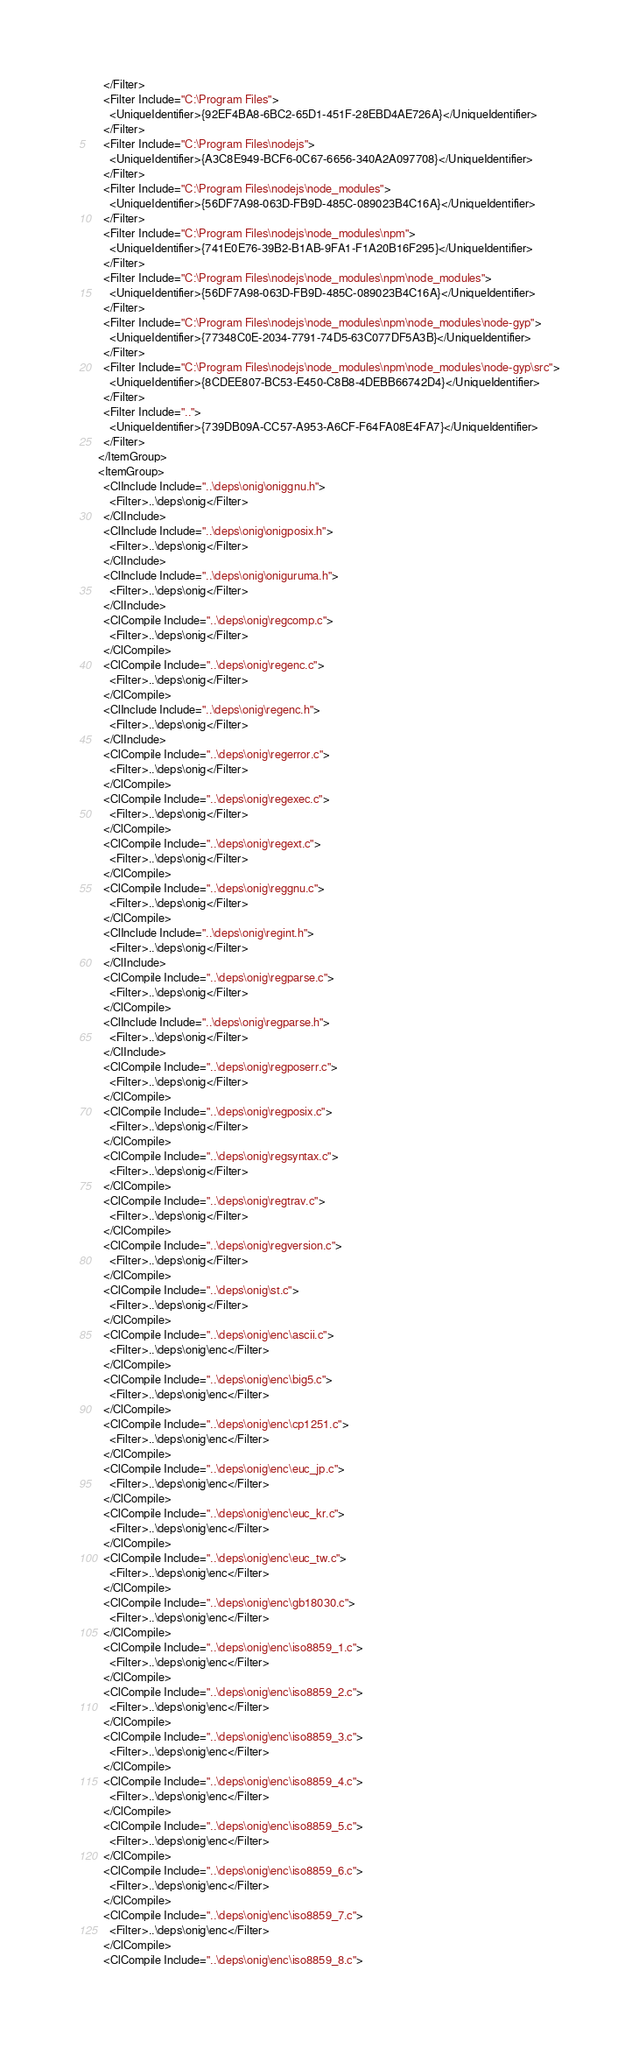<code> <loc_0><loc_0><loc_500><loc_500><_XML_>    </Filter>
    <Filter Include="C:\Program Files">
      <UniqueIdentifier>{92EF4BA8-6BC2-65D1-451F-28EBD4AE726A}</UniqueIdentifier>
    </Filter>
    <Filter Include="C:\Program Files\nodejs">
      <UniqueIdentifier>{A3C8E949-BCF6-0C67-6656-340A2A097708}</UniqueIdentifier>
    </Filter>
    <Filter Include="C:\Program Files\nodejs\node_modules">
      <UniqueIdentifier>{56DF7A98-063D-FB9D-485C-089023B4C16A}</UniqueIdentifier>
    </Filter>
    <Filter Include="C:\Program Files\nodejs\node_modules\npm">
      <UniqueIdentifier>{741E0E76-39B2-B1AB-9FA1-F1A20B16F295}</UniqueIdentifier>
    </Filter>
    <Filter Include="C:\Program Files\nodejs\node_modules\npm\node_modules">
      <UniqueIdentifier>{56DF7A98-063D-FB9D-485C-089023B4C16A}</UniqueIdentifier>
    </Filter>
    <Filter Include="C:\Program Files\nodejs\node_modules\npm\node_modules\node-gyp">
      <UniqueIdentifier>{77348C0E-2034-7791-74D5-63C077DF5A3B}</UniqueIdentifier>
    </Filter>
    <Filter Include="C:\Program Files\nodejs\node_modules\npm\node_modules\node-gyp\src">
      <UniqueIdentifier>{8CDEE807-BC53-E450-C8B8-4DEBB66742D4}</UniqueIdentifier>
    </Filter>
    <Filter Include="..">
      <UniqueIdentifier>{739DB09A-CC57-A953-A6CF-F64FA08E4FA7}</UniqueIdentifier>
    </Filter>
  </ItemGroup>
  <ItemGroup>
    <ClInclude Include="..\deps\onig\oniggnu.h">
      <Filter>..\deps\onig</Filter>
    </ClInclude>
    <ClInclude Include="..\deps\onig\onigposix.h">
      <Filter>..\deps\onig</Filter>
    </ClInclude>
    <ClInclude Include="..\deps\onig\oniguruma.h">
      <Filter>..\deps\onig</Filter>
    </ClInclude>
    <ClCompile Include="..\deps\onig\regcomp.c">
      <Filter>..\deps\onig</Filter>
    </ClCompile>
    <ClCompile Include="..\deps\onig\regenc.c">
      <Filter>..\deps\onig</Filter>
    </ClCompile>
    <ClInclude Include="..\deps\onig\regenc.h">
      <Filter>..\deps\onig</Filter>
    </ClInclude>
    <ClCompile Include="..\deps\onig\regerror.c">
      <Filter>..\deps\onig</Filter>
    </ClCompile>
    <ClCompile Include="..\deps\onig\regexec.c">
      <Filter>..\deps\onig</Filter>
    </ClCompile>
    <ClCompile Include="..\deps\onig\regext.c">
      <Filter>..\deps\onig</Filter>
    </ClCompile>
    <ClCompile Include="..\deps\onig\reggnu.c">
      <Filter>..\deps\onig</Filter>
    </ClCompile>
    <ClInclude Include="..\deps\onig\regint.h">
      <Filter>..\deps\onig</Filter>
    </ClInclude>
    <ClCompile Include="..\deps\onig\regparse.c">
      <Filter>..\deps\onig</Filter>
    </ClCompile>
    <ClInclude Include="..\deps\onig\regparse.h">
      <Filter>..\deps\onig</Filter>
    </ClInclude>
    <ClCompile Include="..\deps\onig\regposerr.c">
      <Filter>..\deps\onig</Filter>
    </ClCompile>
    <ClCompile Include="..\deps\onig\regposix.c">
      <Filter>..\deps\onig</Filter>
    </ClCompile>
    <ClCompile Include="..\deps\onig\regsyntax.c">
      <Filter>..\deps\onig</Filter>
    </ClCompile>
    <ClCompile Include="..\deps\onig\regtrav.c">
      <Filter>..\deps\onig</Filter>
    </ClCompile>
    <ClCompile Include="..\deps\onig\regversion.c">
      <Filter>..\deps\onig</Filter>
    </ClCompile>
    <ClCompile Include="..\deps\onig\st.c">
      <Filter>..\deps\onig</Filter>
    </ClCompile>
    <ClCompile Include="..\deps\onig\enc\ascii.c">
      <Filter>..\deps\onig\enc</Filter>
    </ClCompile>
    <ClCompile Include="..\deps\onig\enc\big5.c">
      <Filter>..\deps\onig\enc</Filter>
    </ClCompile>
    <ClCompile Include="..\deps\onig\enc\cp1251.c">
      <Filter>..\deps\onig\enc</Filter>
    </ClCompile>
    <ClCompile Include="..\deps\onig\enc\euc_jp.c">
      <Filter>..\deps\onig\enc</Filter>
    </ClCompile>
    <ClCompile Include="..\deps\onig\enc\euc_kr.c">
      <Filter>..\deps\onig\enc</Filter>
    </ClCompile>
    <ClCompile Include="..\deps\onig\enc\euc_tw.c">
      <Filter>..\deps\onig\enc</Filter>
    </ClCompile>
    <ClCompile Include="..\deps\onig\enc\gb18030.c">
      <Filter>..\deps\onig\enc</Filter>
    </ClCompile>
    <ClCompile Include="..\deps\onig\enc\iso8859_1.c">
      <Filter>..\deps\onig\enc</Filter>
    </ClCompile>
    <ClCompile Include="..\deps\onig\enc\iso8859_2.c">
      <Filter>..\deps\onig\enc</Filter>
    </ClCompile>
    <ClCompile Include="..\deps\onig\enc\iso8859_3.c">
      <Filter>..\deps\onig\enc</Filter>
    </ClCompile>
    <ClCompile Include="..\deps\onig\enc\iso8859_4.c">
      <Filter>..\deps\onig\enc</Filter>
    </ClCompile>
    <ClCompile Include="..\deps\onig\enc\iso8859_5.c">
      <Filter>..\deps\onig\enc</Filter>
    </ClCompile>
    <ClCompile Include="..\deps\onig\enc\iso8859_6.c">
      <Filter>..\deps\onig\enc</Filter>
    </ClCompile>
    <ClCompile Include="..\deps\onig\enc\iso8859_7.c">
      <Filter>..\deps\onig\enc</Filter>
    </ClCompile>
    <ClCompile Include="..\deps\onig\enc\iso8859_8.c"></code> 